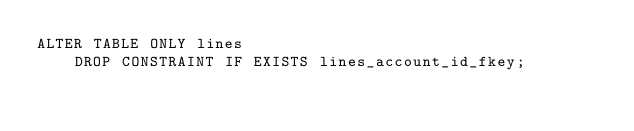Convert code to text. <code><loc_0><loc_0><loc_500><loc_500><_SQL_>ALTER TABLE ONLY lines
    DROP CONSTRAINT IF EXISTS lines_account_id_fkey;</code> 